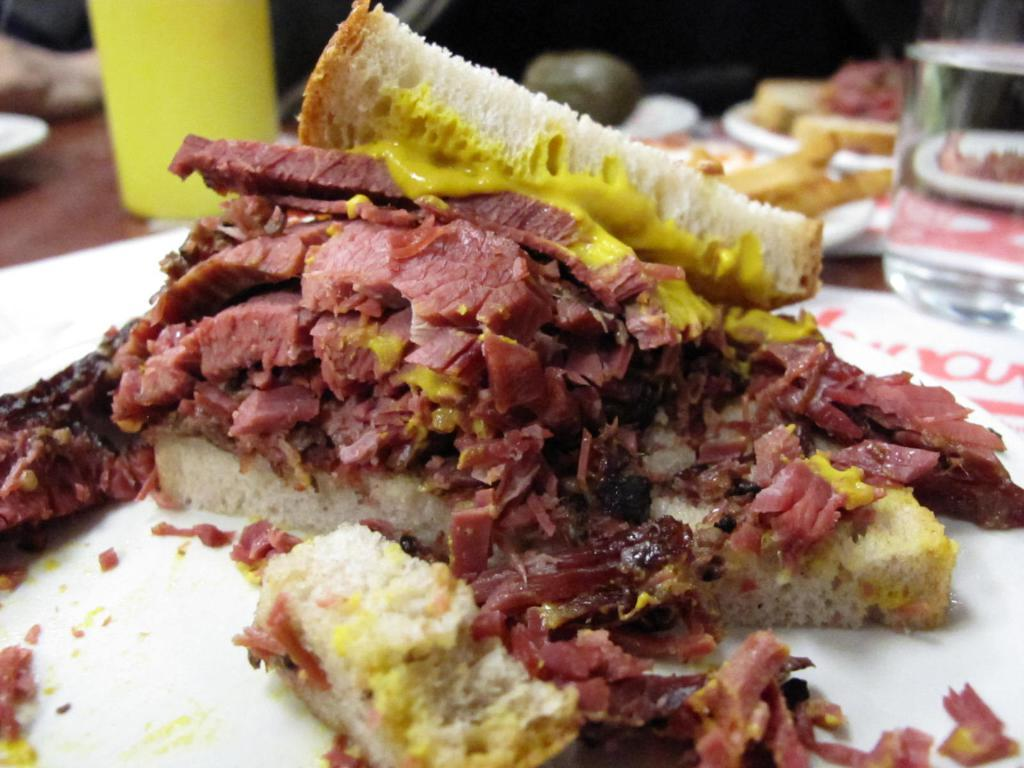What is on the plate that is visible in the image? There is food on the plate in the image. What else can be seen in the image besides the plate and food? There are glasses visible in the image. What type of bells can be heard ringing in the image? There are no bells present in the image, and therefore no sound can be heard. 